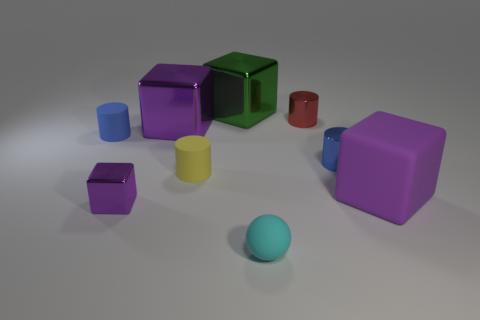How many purple cubes must be subtracted to get 1 purple cubes? 2 Subtract all blue cylinders. How many purple cubes are left? 3 Add 1 large shiny things. How many objects exist? 10 Subtract all spheres. How many objects are left? 8 Subtract 0 yellow cubes. How many objects are left? 9 Subtract all small cyan cylinders. Subtract all tiny yellow matte objects. How many objects are left? 8 Add 1 yellow objects. How many yellow objects are left? 2 Add 5 tiny gray rubber blocks. How many tiny gray rubber blocks exist? 5 